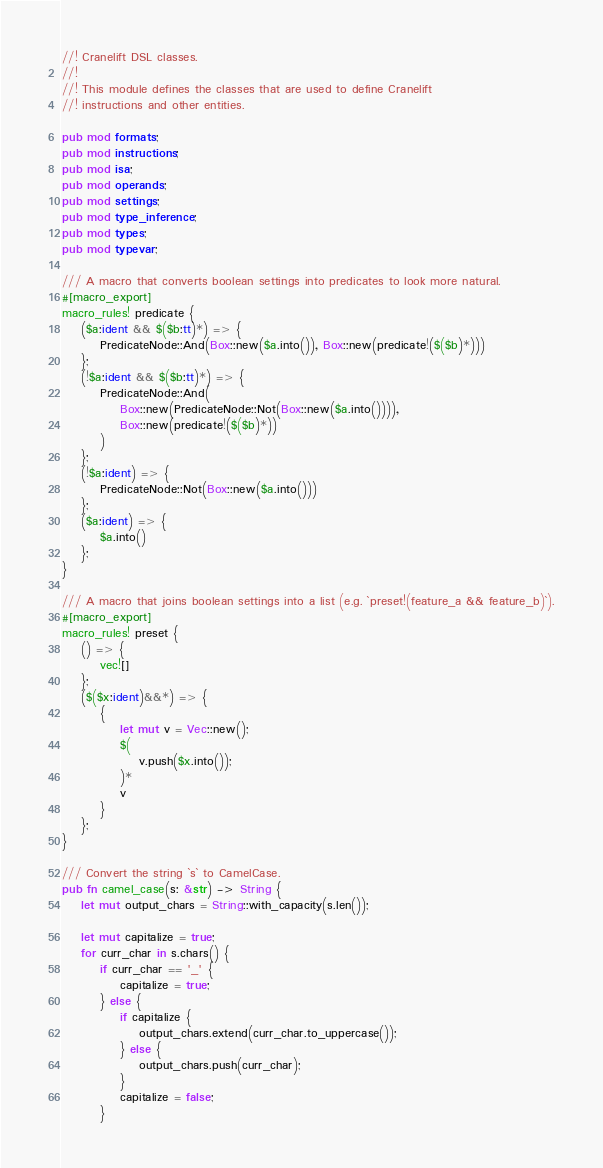<code> <loc_0><loc_0><loc_500><loc_500><_Rust_>//! Cranelift DSL classes.
//!
//! This module defines the classes that are used to define Cranelift
//! instructions and other entities.

pub mod formats;
pub mod instructions;
pub mod isa;
pub mod operands;
pub mod settings;
pub mod type_inference;
pub mod types;
pub mod typevar;

/// A macro that converts boolean settings into predicates to look more natural.
#[macro_export]
macro_rules! predicate {
    ($a:ident && $($b:tt)*) => {
        PredicateNode::And(Box::new($a.into()), Box::new(predicate!($($b)*)))
    };
    (!$a:ident && $($b:tt)*) => {
        PredicateNode::And(
            Box::new(PredicateNode::Not(Box::new($a.into()))),
            Box::new(predicate!($($b)*))
        )
    };
    (!$a:ident) => {
        PredicateNode::Not(Box::new($a.into()))
    };
    ($a:ident) => {
        $a.into()
    };
}

/// A macro that joins boolean settings into a list (e.g. `preset!(feature_a && feature_b)`).
#[macro_export]
macro_rules! preset {
    () => {
        vec![]
    };
    ($($x:ident)&&*) => {
        {
            let mut v = Vec::new();
            $(
                v.push($x.into());
            )*
            v
        }
    };
}

/// Convert the string `s` to CamelCase.
pub fn camel_case(s: &str) -> String {
    let mut output_chars = String::with_capacity(s.len());

    let mut capitalize = true;
    for curr_char in s.chars() {
        if curr_char == '_' {
            capitalize = true;
        } else {
            if capitalize {
                output_chars.extend(curr_char.to_uppercase());
            } else {
                output_chars.push(curr_char);
            }
            capitalize = false;
        }</code> 